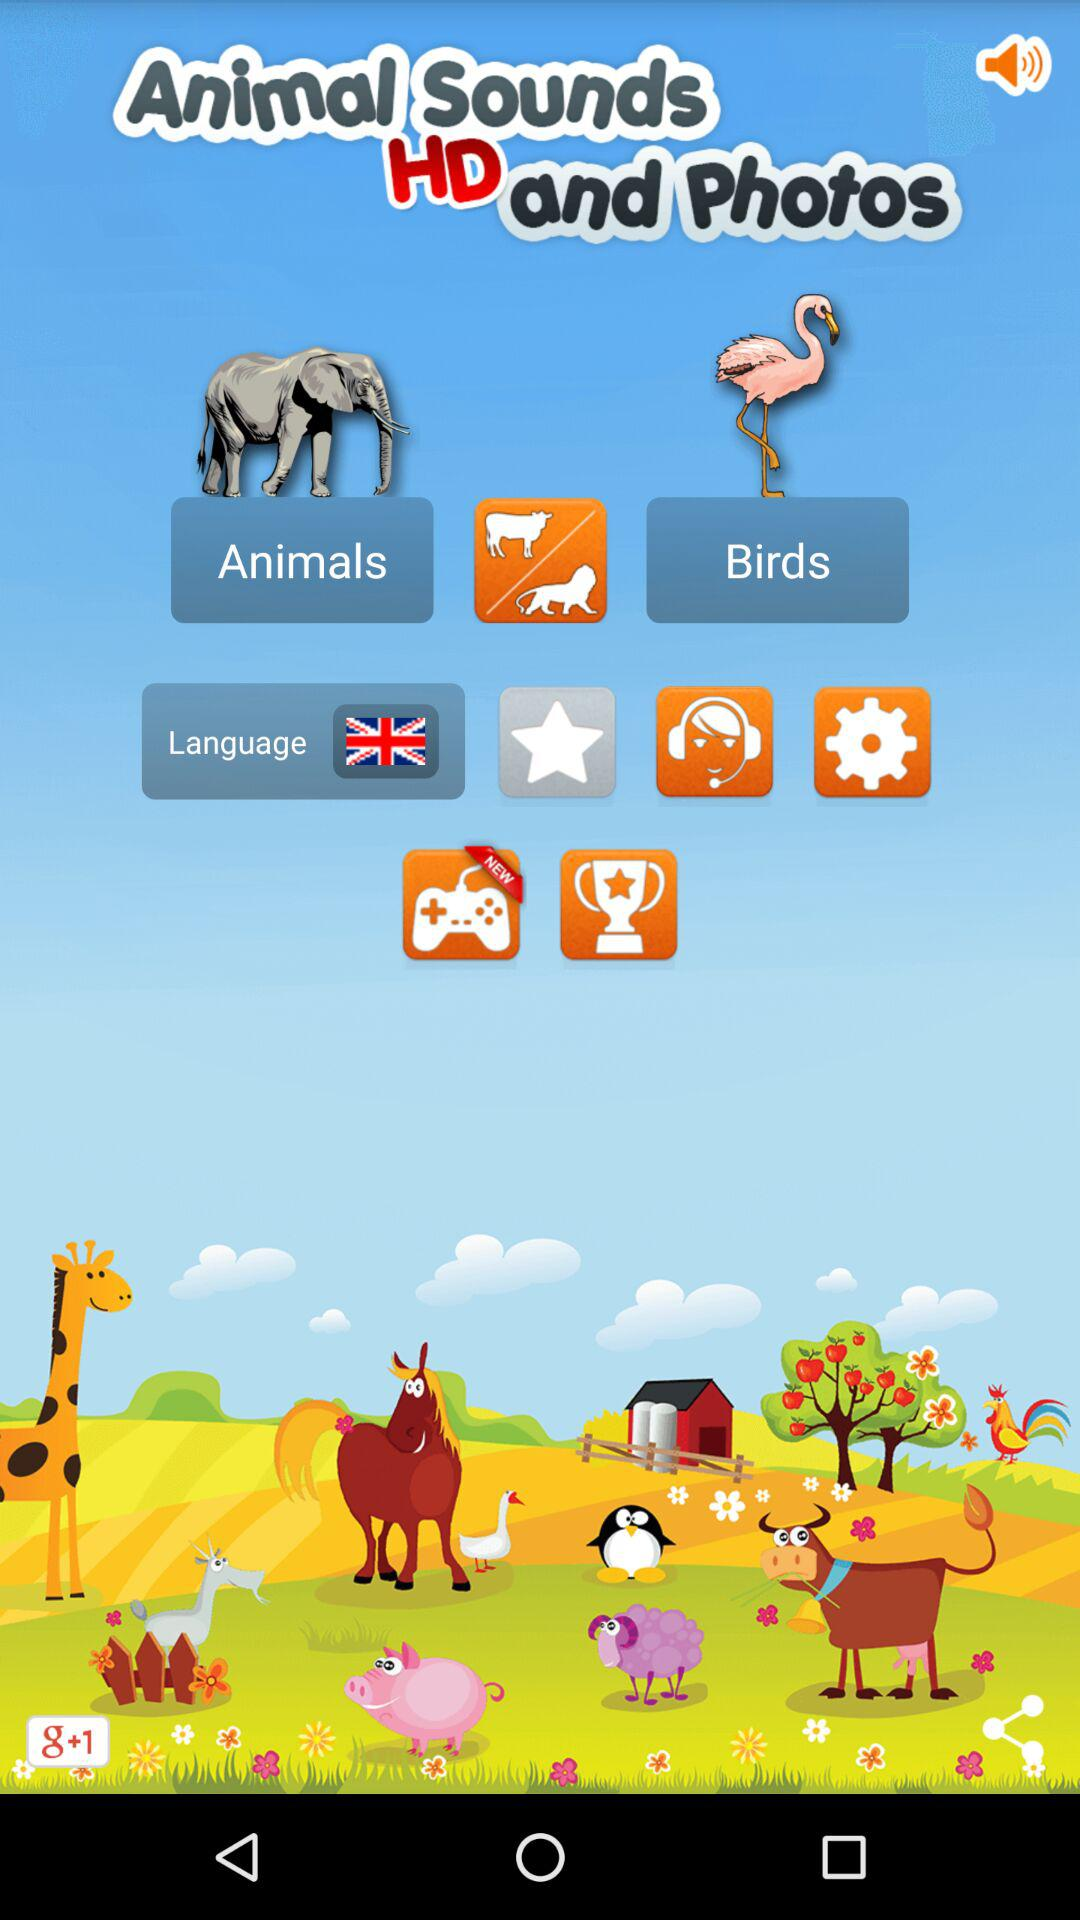What is the name of the application? The name of the application is "Animal Sounds HD and Photos". 